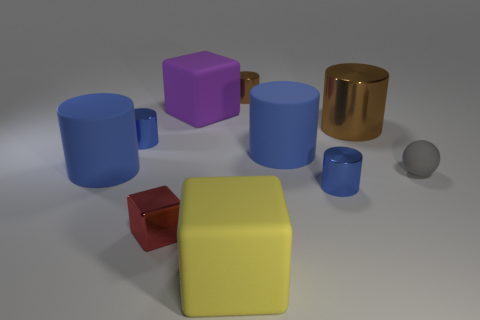How many things are either tiny rubber spheres or tiny things that are behind the red shiny block?
Make the answer very short. 4. Is the number of big cubes that are left of the yellow object greater than the number of red shiny blocks that are on the left side of the big purple rubber block?
Offer a very short reply. No. What is the block behind the big blue rubber cylinder left of the matte block in front of the big brown object made of?
Ensure brevity in your answer.  Rubber. There is a tiny brown thing that is the same material as the red object; what shape is it?
Keep it short and to the point. Cylinder. Is there a large thing to the right of the small blue metal cylinder that is in front of the ball?
Offer a terse response. Yes. The gray rubber thing has what size?
Provide a succinct answer. Small. How many things are either tiny cubes or large purple rubber cylinders?
Your response must be concise. 1. Are the large blue cylinder on the right side of the small red block and the red block that is in front of the purple matte object made of the same material?
Make the answer very short. No. What color is the small object that is the same material as the large yellow cube?
Keep it short and to the point. Gray. How many metallic objects have the same size as the sphere?
Your answer should be very brief. 4. 